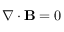Convert formula to latex. <formula><loc_0><loc_0><loc_500><loc_500>\nabla \cdot B = 0</formula> 